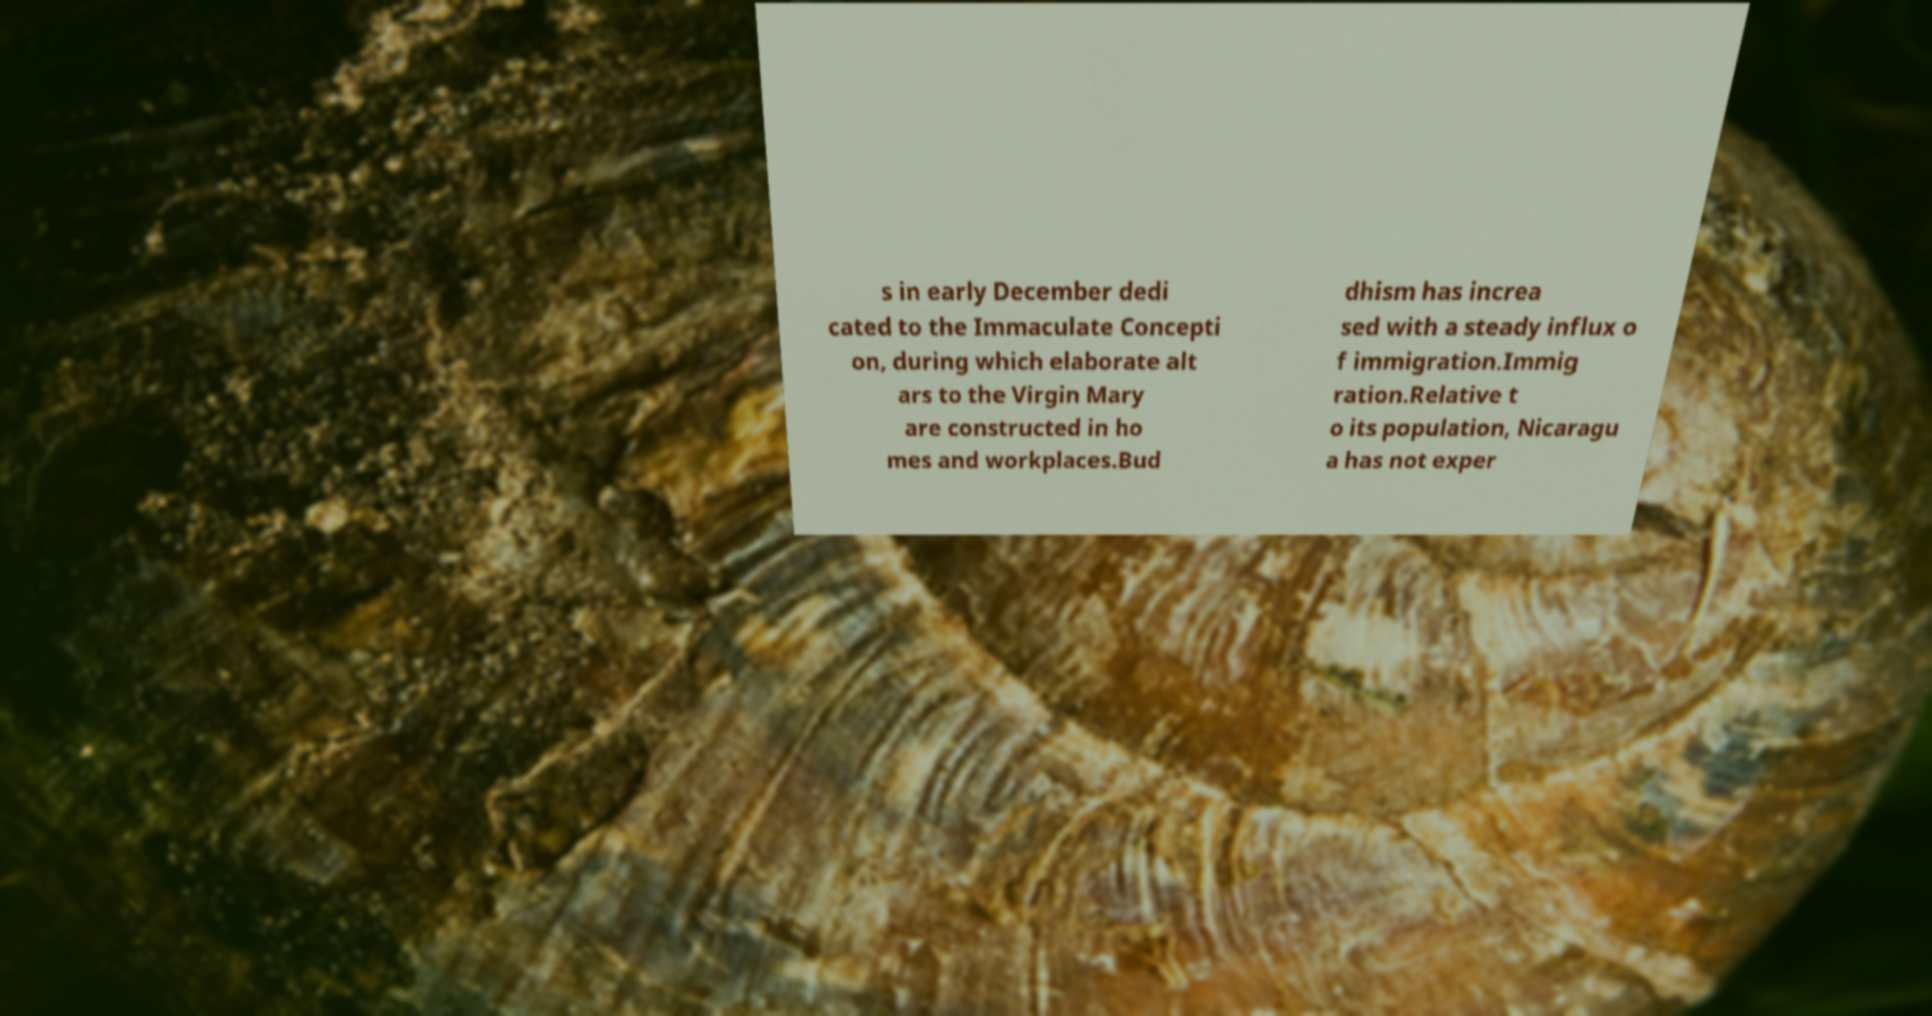Can you accurately transcribe the text from the provided image for me? s in early December dedi cated to the Immaculate Concepti on, during which elaborate alt ars to the Virgin Mary are constructed in ho mes and workplaces.Bud dhism has increa sed with a steady influx o f immigration.Immig ration.Relative t o its population, Nicaragu a has not exper 